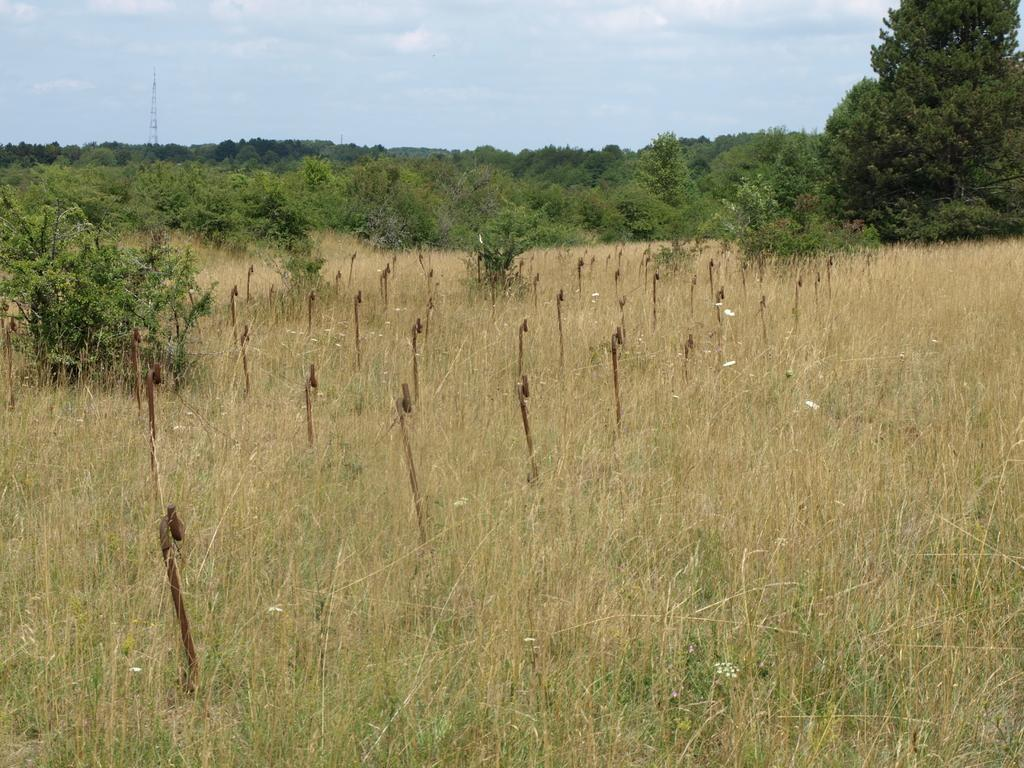What type of vegetation can be seen in the image? There is grass, plants, and trees in the image. What else is present on the ground in the image? There are other objects on the ground in the image. What can be seen in the background of the image? The sky is visible in the background of the image. What type of soap is being used to clean the glass in the image? There is no soap or glass present in the image; it features grass, plants, trees, and other objects on the ground. 